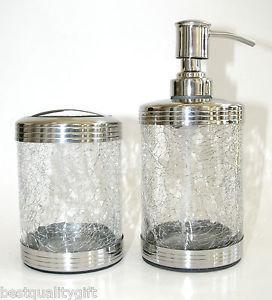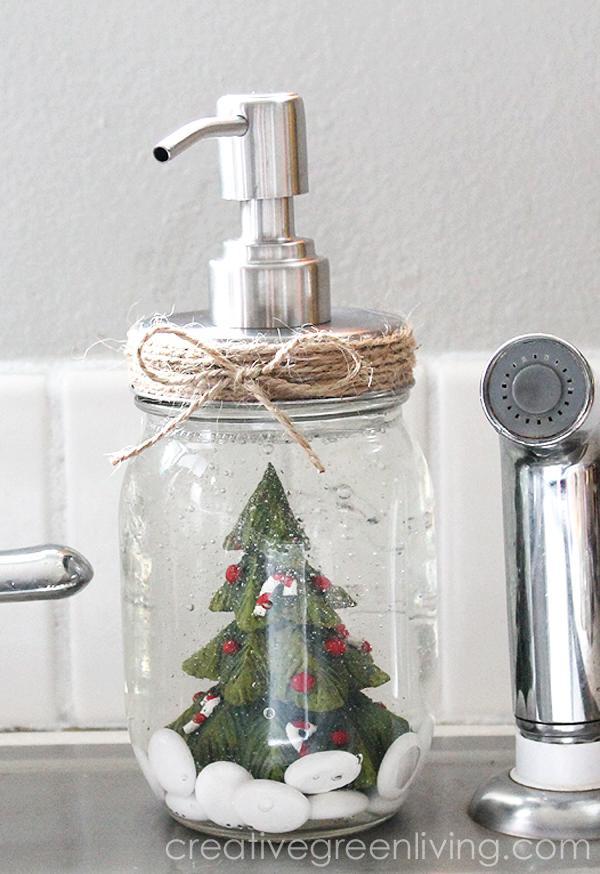The first image is the image on the left, the second image is the image on the right. Given the left and right images, does the statement "Each image shows a pair of pump dispensers, and each pair of dispensers is shown with a caddy holder." hold true? Answer yes or no. No. The first image is the image on the left, the second image is the image on the right. Analyze the images presented: Is the assertion "At least one image shows exactly three containers." valid? Answer yes or no. No. The first image is the image on the left, the second image is the image on the right. Assess this claim about the two images: "Two jars are sitting in a carrier in one of the images.". Correct or not? Answer yes or no. No. The first image is the image on the left, the second image is the image on the right. Given the left and right images, does the statement "In each image the soap dispenser is filled with liquid." hold true? Answer yes or no. No. 